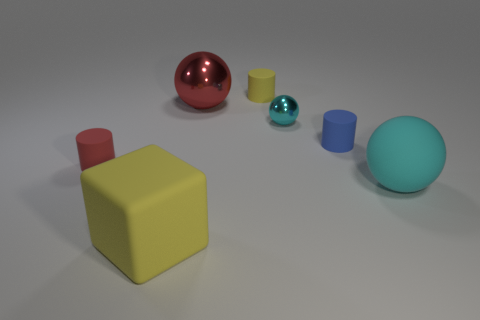What is the material of the other ball that is the same color as the big rubber sphere?
Your answer should be very brief. Metal. What size is the other cyan metal object that is the same shape as the big metal object?
Provide a short and direct response. Small. Is the red shiny thing the same shape as the tiny shiny object?
Your answer should be compact. Yes. What material is the red thing right of the thing in front of the big cyan ball that is in front of the red matte thing?
Your answer should be very brief. Metal. There is a big ball left of the large matte object on the right side of the big yellow rubber cube; what is its material?
Ensure brevity in your answer.  Metal. Is the number of blue cylinders behind the tiny yellow cylinder less than the number of big cyan rubber spheres?
Give a very brief answer. Yes. There is a thing that is behind the large red metallic ball; what shape is it?
Make the answer very short. Cylinder. Does the red shiny ball have the same size as the rubber object in front of the cyan matte ball?
Keep it short and to the point. Yes. Are there any other spheres made of the same material as the tiny sphere?
Provide a succinct answer. Yes. What number of spheres are either small red objects or matte things?
Provide a succinct answer. 1. 